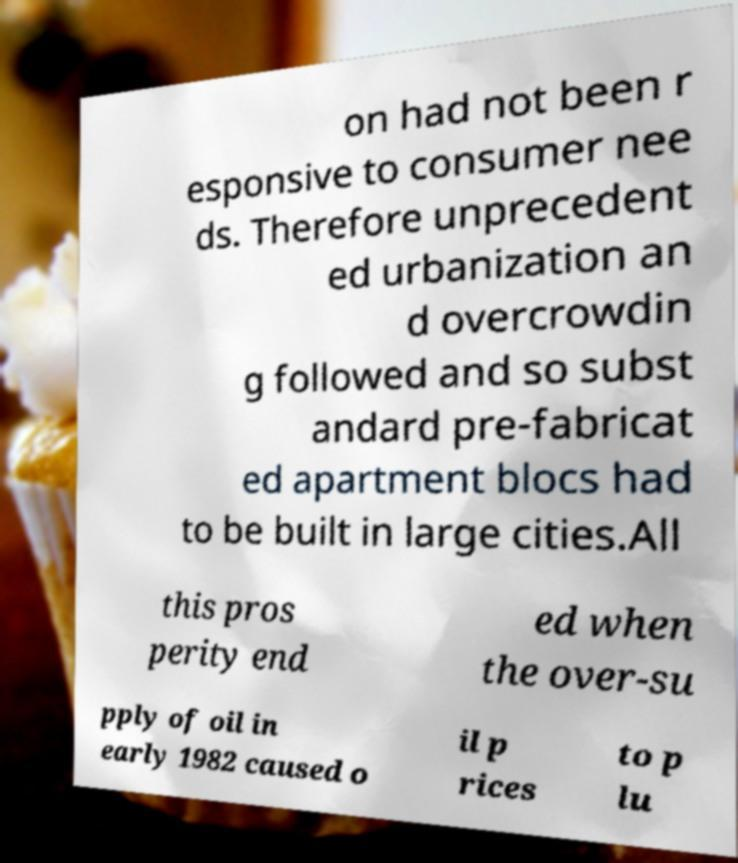Can you read and provide the text displayed in the image?This photo seems to have some interesting text. Can you extract and type it out for me? on had not been r esponsive to consumer nee ds. Therefore unprecedent ed urbanization an d overcrowdin g followed and so subst andard pre-fabricat ed apartment blocs had to be built in large cities.All this pros perity end ed when the over-su pply of oil in early 1982 caused o il p rices to p lu 